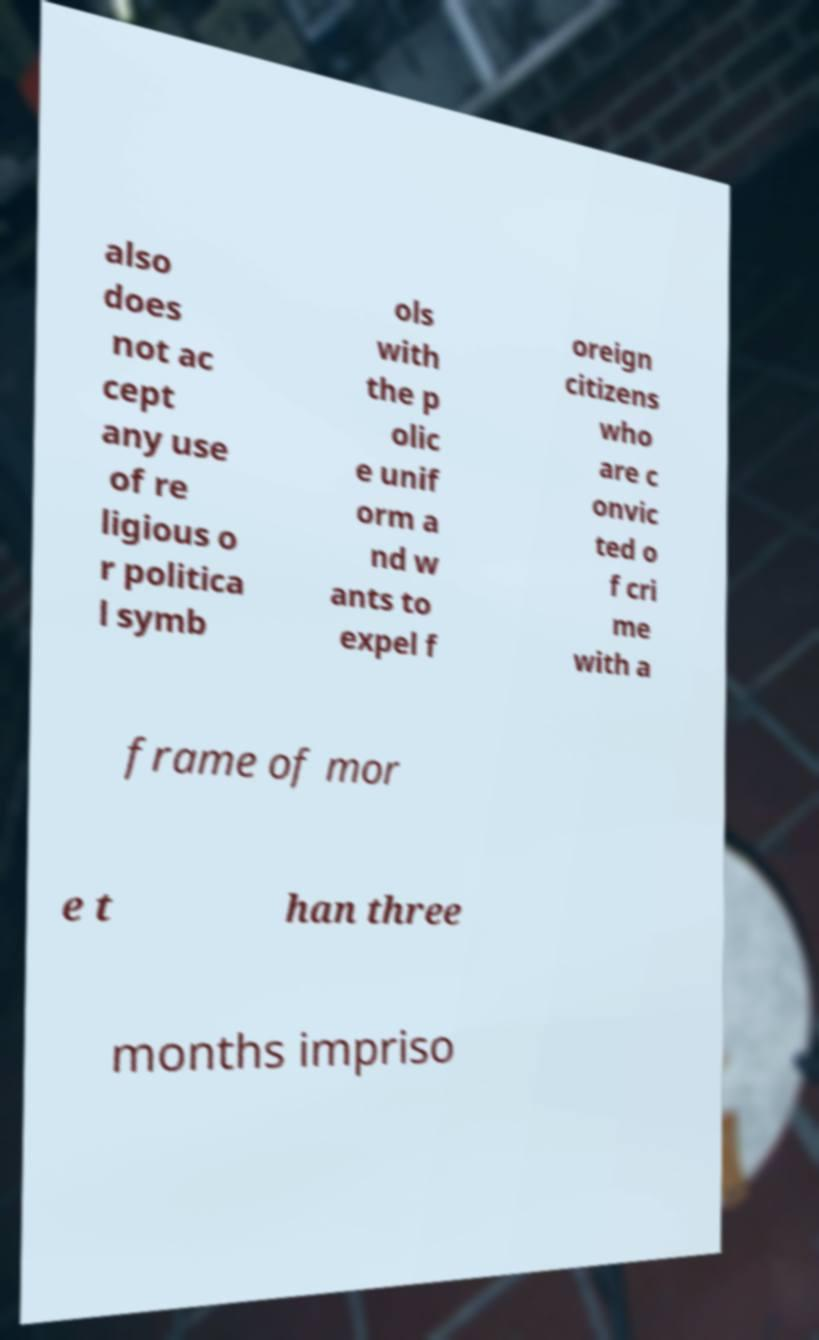Can you read and provide the text displayed in the image?This photo seems to have some interesting text. Can you extract and type it out for me? also does not ac cept any use of re ligious o r politica l symb ols with the p olic e unif orm a nd w ants to expel f oreign citizens who are c onvic ted o f cri me with a frame of mor e t han three months impriso 